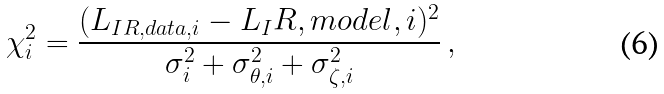Convert formula to latex. <formula><loc_0><loc_0><loc_500><loc_500>\chi _ { i } ^ { 2 } = \frac { ( L _ { I R , d a t a , i } - L _ { I } R , m o d e l , i ) ^ { 2 } } { \sigma _ { i } ^ { 2 } + \sigma _ { \theta , i } ^ { 2 } + \sigma _ { \zeta , i } ^ { 2 } } \, ,</formula> 